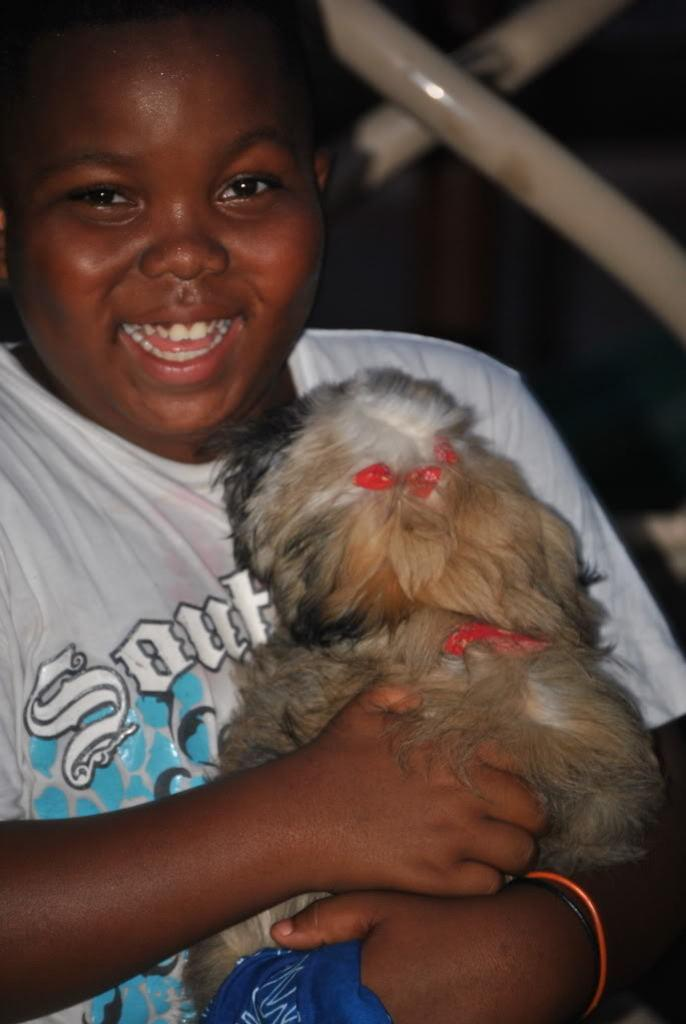What is the main subject of the image? There is a person in the image. What is the person doing in the image? The person is smiling. What is the person holding in the image? The person is holding a dog. What type of crime is being committed in the image? There is no crime being committed in the image; it features a person smiling and holding a dog. What view can be seen in the background of the image? The image does not show a view or background; it focuses on the person and the dog. 